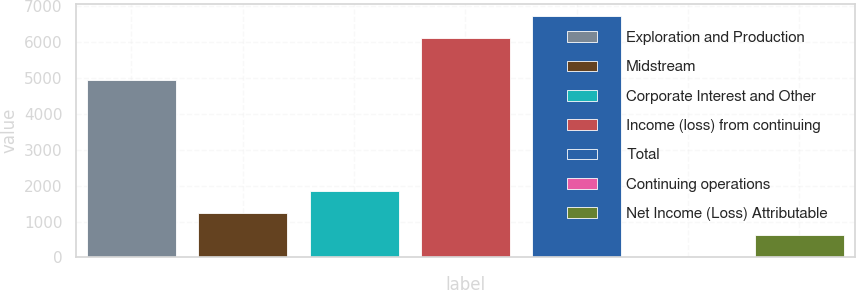<chart> <loc_0><loc_0><loc_500><loc_500><bar_chart><fcel>Exploration and Production<fcel>Midstream<fcel>Corporate Interest and Other<fcel>Income (loss) from continuing<fcel>Total<fcel>Continuing operations<fcel>Net Income (Loss) Attributable<nl><fcel>4964<fcel>1242.34<fcel>1853.55<fcel>6132<fcel>6743.21<fcel>19.92<fcel>631.13<nl></chart> 